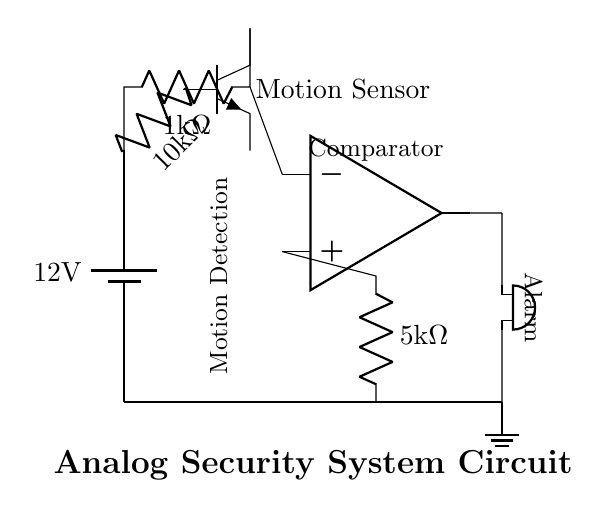What is the power supply voltage? The diagram shows a battery labeled with a voltage of 12 volts. This indicates the power supply voltage for the circuit.
Answer: 12 volts What component detects motion? The circuit shows a component labeled "Motion Sensor" which is responsible for detecting motion.
Answer: Motion Sensor What is the resistance value of the first resistor? The circuit diagram indicates that the first resistor connected to the motion sensor has a resistance of 10 kilohms.
Answer: 10 kilohms What type of component is represented at the far right of the circuit? The component at the far right is labeled as a "buzzer," which is an alarm signaling device in the circuit.
Answer: Buzzer How many resistors are in the circuit? There are three resistors shown in the circuit diagram, corresponding to the two labeled resistors and one incorporated with the motion sensor.
Answer: Three What is the role of the comparator in the circuit? The comparator takes the signal from the motion sensor and compares it against a reference voltage to determine if the alarm should be triggered or not.
Answer: Signal processing What component produces an alarm sound? The buzzer is responsible for producing the alarm sound in case the motion sensor detects any motion.
Answer: Buzzer 